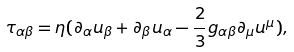Convert formula to latex. <formula><loc_0><loc_0><loc_500><loc_500>\tau _ { \alpha \beta } = \eta ( \partial _ { \alpha } u _ { \beta } + \partial _ { \beta } u _ { \alpha } - \frac { 2 } { 3 } g _ { \alpha \beta } \partial _ { \mu } u ^ { \mu } ) ,</formula> 